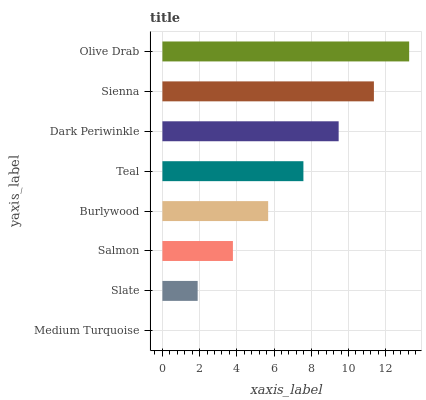Is Medium Turquoise the minimum?
Answer yes or no. Yes. Is Olive Drab the maximum?
Answer yes or no. Yes. Is Slate the minimum?
Answer yes or no. No. Is Slate the maximum?
Answer yes or no. No. Is Slate greater than Medium Turquoise?
Answer yes or no. Yes. Is Medium Turquoise less than Slate?
Answer yes or no. Yes. Is Medium Turquoise greater than Slate?
Answer yes or no. No. Is Slate less than Medium Turquoise?
Answer yes or no. No. Is Teal the high median?
Answer yes or no. Yes. Is Burlywood the low median?
Answer yes or no. Yes. Is Slate the high median?
Answer yes or no. No. Is Dark Periwinkle the low median?
Answer yes or no. No. 